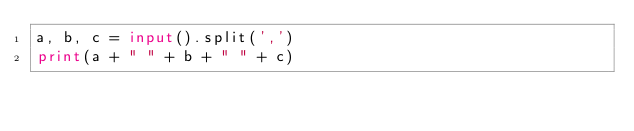Convert code to text. <code><loc_0><loc_0><loc_500><loc_500><_Python_>a, b, c = input().split(',')
print(a + " " + b + " " + c)
</code> 